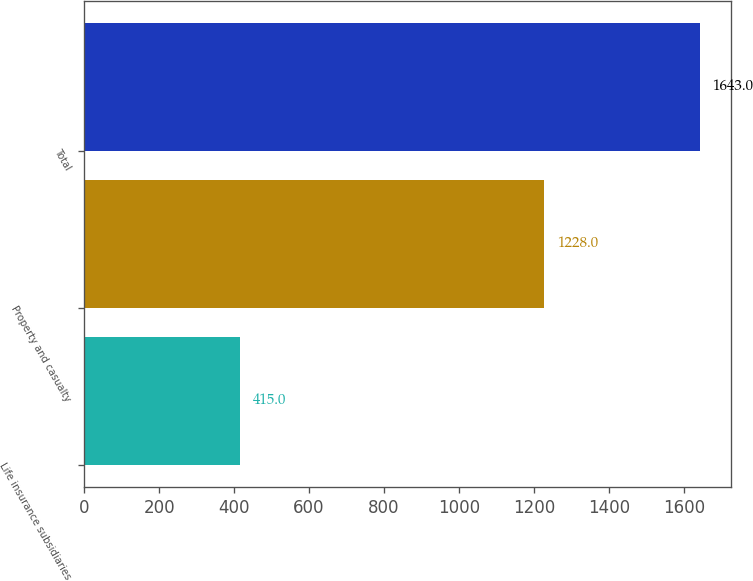Convert chart to OTSL. <chart><loc_0><loc_0><loc_500><loc_500><bar_chart><fcel>Life insurance subsidiaries<fcel>Property and casualty<fcel>Total<nl><fcel>415<fcel>1228<fcel>1643<nl></chart> 